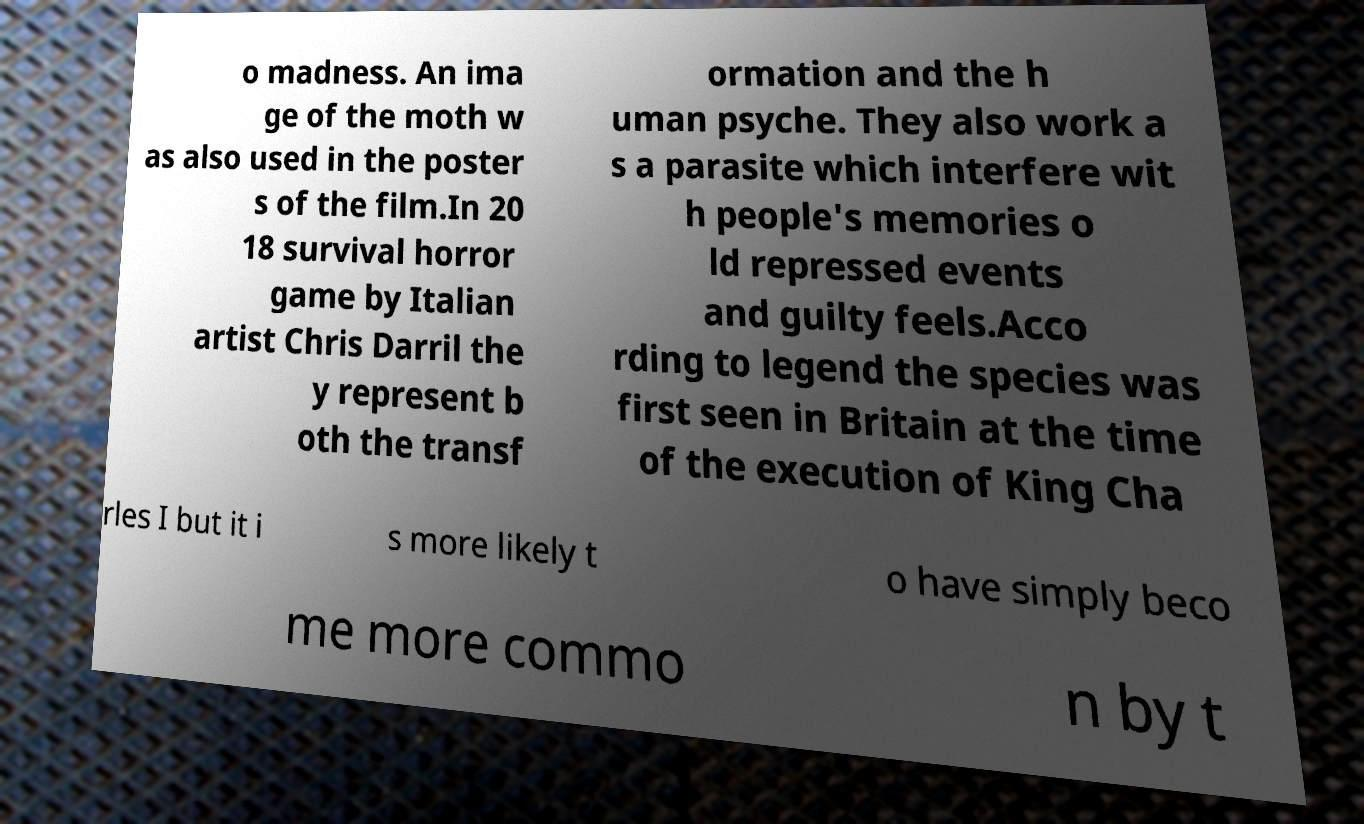Please read and relay the text visible in this image. What does it say? o madness. An ima ge of the moth w as also used in the poster s of the film.In 20 18 survival horror game by Italian artist Chris Darril the y represent b oth the transf ormation and the h uman psyche. They also work a s a parasite which interfere wit h people's memories o ld repressed events and guilty feels.Acco rding to legend the species was first seen in Britain at the time of the execution of King Cha rles I but it i s more likely t o have simply beco me more commo n by t 